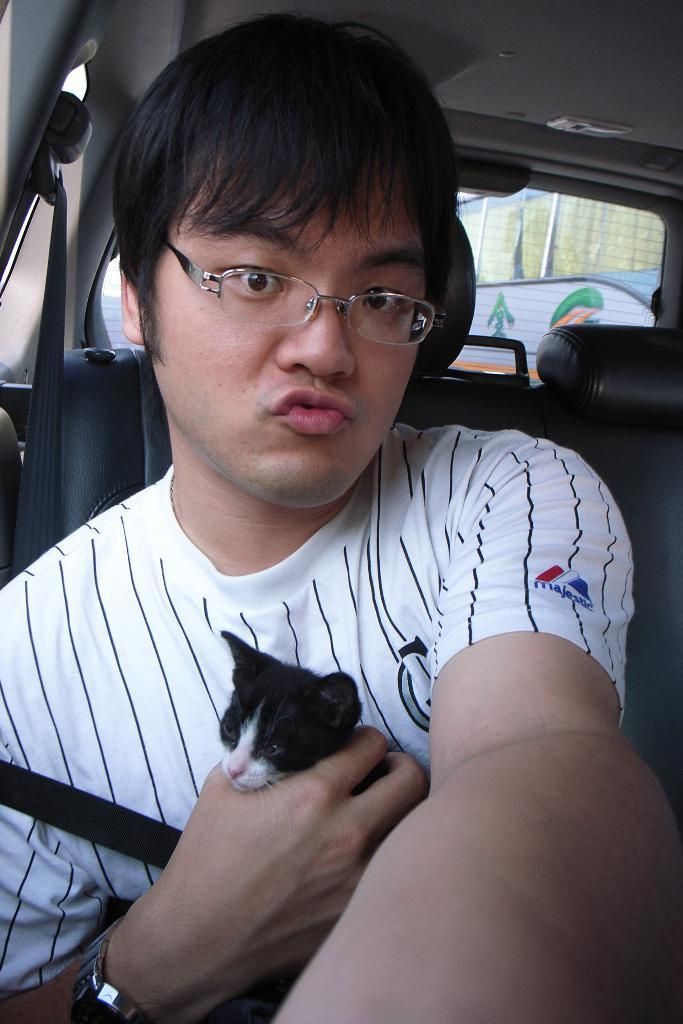Who is present in the image? There is a man in the image. What is the man doing in the image? The man is sitting inside a car. Is the man holding anything in the image? Yes, the man is holding a cat in his right hand. What discovery did the man make while sitting in the car? There is no indication in the image of a discovery made by the man. 